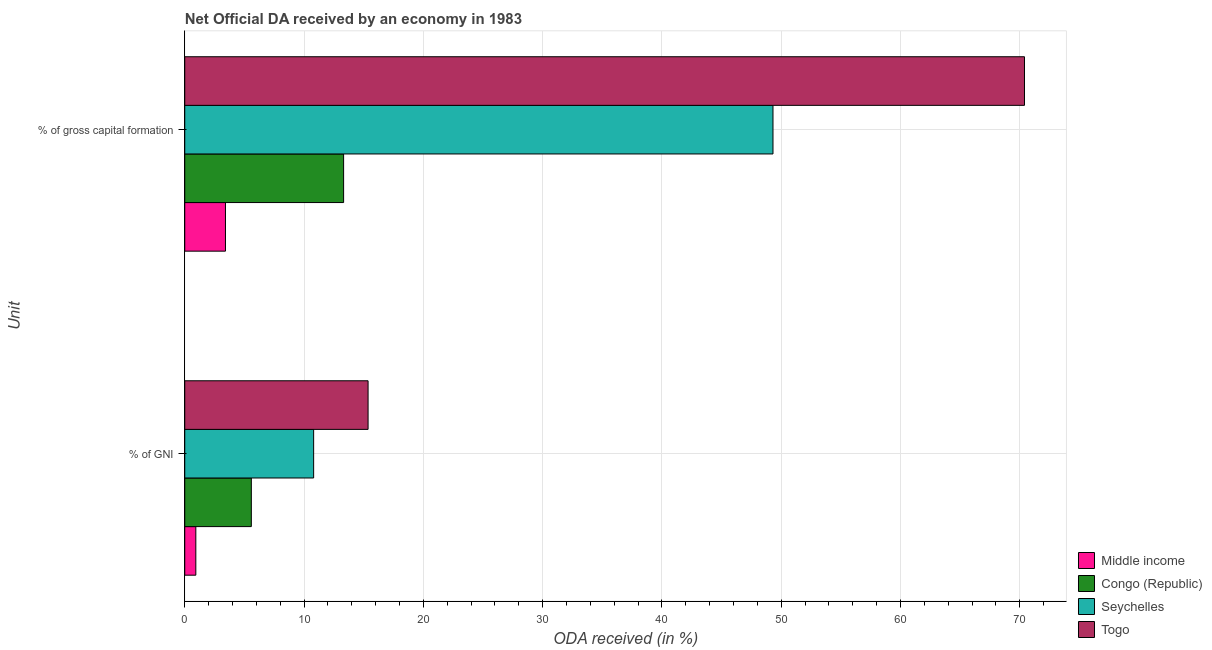How many groups of bars are there?
Give a very brief answer. 2. Are the number of bars on each tick of the Y-axis equal?
Ensure brevity in your answer.  Yes. What is the label of the 1st group of bars from the top?
Your answer should be compact. % of gross capital formation. What is the oda received as percentage of gross capital formation in Seychelles?
Your answer should be very brief. 49.31. Across all countries, what is the maximum oda received as percentage of gross capital formation?
Your answer should be compact. 70.39. Across all countries, what is the minimum oda received as percentage of gni?
Your response must be concise. 0.93. In which country was the oda received as percentage of gross capital formation maximum?
Offer a terse response. Togo. In which country was the oda received as percentage of gross capital formation minimum?
Offer a very short reply. Middle income. What is the total oda received as percentage of gni in the graph?
Your answer should be compact. 32.68. What is the difference between the oda received as percentage of gni in Seychelles and that in Togo?
Keep it short and to the point. -4.56. What is the difference between the oda received as percentage of gross capital formation in Middle income and the oda received as percentage of gni in Togo?
Ensure brevity in your answer.  -11.95. What is the average oda received as percentage of gross capital formation per country?
Give a very brief answer. 34.11. What is the difference between the oda received as percentage of gross capital formation and oda received as percentage of gni in Togo?
Your answer should be compact. 55.03. What is the ratio of the oda received as percentage of gross capital formation in Togo to that in Seychelles?
Your answer should be very brief. 1.43. Is the oda received as percentage of gross capital formation in Seychelles less than that in Congo (Republic)?
Make the answer very short. No. In how many countries, is the oda received as percentage of gni greater than the average oda received as percentage of gni taken over all countries?
Provide a succinct answer. 2. What does the 1st bar from the top in % of gross capital formation represents?
Provide a succinct answer. Togo. What does the 3rd bar from the bottom in % of GNI represents?
Your answer should be compact. Seychelles. Are all the bars in the graph horizontal?
Offer a very short reply. Yes. How many countries are there in the graph?
Provide a short and direct response. 4. What is the difference between two consecutive major ticks on the X-axis?
Your answer should be compact. 10. Are the values on the major ticks of X-axis written in scientific E-notation?
Your answer should be very brief. No. Does the graph contain any zero values?
Offer a terse response. No. Does the graph contain grids?
Make the answer very short. Yes. Where does the legend appear in the graph?
Provide a succinct answer. Bottom right. How many legend labels are there?
Offer a terse response. 4. How are the legend labels stacked?
Ensure brevity in your answer.  Vertical. What is the title of the graph?
Offer a very short reply. Net Official DA received by an economy in 1983. Does "Kenya" appear as one of the legend labels in the graph?
Your response must be concise. No. What is the label or title of the X-axis?
Your answer should be compact. ODA received (in %). What is the label or title of the Y-axis?
Your answer should be compact. Unit. What is the ODA received (in %) in Middle income in % of GNI?
Ensure brevity in your answer.  0.93. What is the ODA received (in %) in Congo (Republic) in % of GNI?
Ensure brevity in your answer.  5.58. What is the ODA received (in %) in Seychelles in % of GNI?
Make the answer very short. 10.8. What is the ODA received (in %) in Togo in % of GNI?
Your answer should be compact. 15.37. What is the ODA received (in %) of Middle income in % of gross capital formation?
Offer a very short reply. 3.41. What is the ODA received (in %) of Congo (Republic) in % of gross capital formation?
Your answer should be very brief. 13.32. What is the ODA received (in %) of Seychelles in % of gross capital formation?
Your answer should be very brief. 49.31. What is the ODA received (in %) of Togo in % of gross capital formation?
Provide a succinct answer. 70.39. Across all Unit, what is the maximum ODA received (in %) of Middle income?
Give a very brief answer. 3.41. Across all Unit, what is the maximum ODA received (in %) in Congo (Republic)?
Offer a very short reply. 13.32. Across all Unit, what is the maximum ODA received (in %) in Seychelles?
Ensure brevity in your answer.  49.31. Across all Unit, what is the maximum ODA received (in %) in Togo?
Offer a terse response. 70.39. Across all Unit, what is the minimum ODA received (in %) of Middle income?
Your answer should be compact. 0.93. Across all Unit, what is the minimum ODA received (in %) in Congo (Republic)?
Make the answer very short. 5.58. Across all Unit, what is the minimum ODA received (in %) in Seychelles?
Your response must be concise. 10.8. Across all Unit, what is the minimum ODA received (in %) in Togo?
Provide a short and direct response. 15.37. What is the total ODA received (in %) in Middle income in the graph?
Keep it short and to the point. 4.34. What is the total ODA received (in %) in Congo (Republic) in the graph?
Provide a succinct answer. 18.9. What is the total ODA received (in %) in Seychelles in the graph?
Keep it short and to the point. 60.11. What is the total ODA received (in %) in Togo in the graph?
Give a very brief answer. 85.76. What is the difference between the ODA received (in %) of Middle income in % of GNI and that in % of gross capital formation?
Make the answer very short. -2.48. What is the difference between the ODA received (in %) in Congo (Republic) in % of GNI and that in % of gross capital formation?
Your response must be concise. -7.74. What is the difference between the ODA received (in %) in Seychelles in % of GNI and that in % of gross capital formation?
Offer a terse response. -38.51. What is the difference between the ODA received (in %) in Togo in % of GNI and that in % of gross capital formation?
Provide a short and direct response. -55.03. What is the difference between the ODA received (in %) in Middle income in % of GNI and the ODA received (in %) in Congo (Republic) in % of gross capital formation?
Make the answer very short. -12.39. What is the difference between the ODA received (in %) in Middle income in % of GNI and the ODA received (in %) in Seychelles in % of gross capital formation?
Provide a succinct answer. -48.38. What is the difference between the ODA received (in %) of Middle income in % of GNI and the ODA received (in %) of Togo in % of gross capital formation?
Your answer should be compact. -69.46. What is the difference between the ODA received (in %) in Congo (Republic) in % of GNI and the ODA received (in %) in Seychelles in % of gross capital formation?
Provide a short and direct response. -43.73. What is the difference between the ODA received (in %) of Congo (Republic) in % of GNI and the ODA received (in %) of Togo in % of gross capital formation?
Your answer should be compact. -64.81. What is the difference between the ODA received (in %) in Seychelles in % of GNI and the ODA received (in %) in Togo in % of gross capital formation?
Make the answer very short. -59.59. What is the average ODA received (in %) of Middle income per Unit?
Offer a very short reply. 2.17. What is the average ODA received (in %) in Congo (Republic) per Unit?
Offer a very short reply. 9.45. What is the average ODA received (in %) of Seychelles per Unit?
Make the answer very short. 30.06. What is the average ODA received (in %) in Togo per Unit?
Your answer should be compact. 42.88. What is the difference between the ODA received (in %) of Middle income and ODA received (in %) of Congo (Republic) in % of GNI?
Provide a succinct answer. -4.65. What is the difference between the ODA received (in %) in Middle income and ODA received (in %) in Seychelles in % of GNI?
Provide a short and direct response. -9.88. What is the difference between the ODA received (in %) of Middle income and ODA received (in %) of Togo in % of GNI?
Ensure brevity in your answer.  -14.44. What is the difference between the ODA received (in %) of Congo (Republic) and ODA received (in %) of Seychelles in % of GNI?
Provide a short and direct response. -5.22. What is the difference between the ODA received (in %) of Congo (Republic) and ODA received (in %) of Togo in % of GNI?
Ensure brevity in your answer.  -9.79. What is the difference between the ODA received (in %) of Seychelles and ODA received (in %) of Togo in % of GNI?
Offer a very short reply. -4.56. What is the difference between the ODA received (in %) of Middle income and ODA received (in %) of Congo (Republic) in % of gross capital formation?
Give a very brief answer. -9.9. What is the difference between the ODA received (in %) of Middle income and ODA received (in %) of Seychelles in % of gross capital formation?
Offer a terse response. -45.9. What is the difference between the ODA received (in %) of Middle income and ODA received (in %) of Togo in % of gross capital formation?
Give a very brief answer. -66.98. What is the difference between the ODA received (in %) in Congo (Republic) and ODA received (in %) in Seychelles in % of gross capital formation?
Your answer should be very brief. -35.99. What is the difference between the ODA received (in %) of Congo (Republic) and ODA received (in %) of Togo in % of gross capital formation?
Provide a short and direct response. -57.08. What is the difference between the ODA received (in %) in Seychelles and ODA received (in %) in Togo in % of gross capital formation?
Provide a succinct answer. -21.08. What is the ratio of the ODA received (in %) in Middle income in % of GNI to that in % of gross capital formation?
Make the answer very short. 0.27. What is the ratio of the ODA received (in %) in Congo (Republic) in % of GNI to that in % of gross capital formation?
Your answer should be very brief. 0.42. What is the ratio of the ODA received (in %) of Seychelles in % of GNI to that in % of gross capital formation?
Offer a very short reply. 0.22. What is the ratio of the ODA received (in %) of Togo in % of GNI to that in % of gross capital formation?
Offer a terse response. 0.22. What is the difference between the highest and the second highest ODA received (in %) in Middle income?
Ensure brevity in your answer.  2.48. What is the difference between the highest and the second highest ODA received (in %) in Congo (Republic)?
Provide a succinct answer. 7.74. What is the difference between the highest and the second highest ODA received (in %) of Seychelles?
Your response must be concise. 38.51. What is the difference between the highest and the second highest ODA received (in %) in Togo?
Offer a terse response. 55.03. What is the difference between the highest and the lowest ODA received (in %) in Middle income?
Offer a very short reply. 2.48. What is the difference between the highest and the lowest ODA received (in %) of Congo (Republic)?
Offer a terse response. 7.74. What is the difference between the highest and the lowest ODA received (in %) in Seychelles?
Keep it short and to the point. 38.51. What is the difference between the highest and the lowest ODA received (in %) of Togo?
Ensure brevity in your answer.  55.03. 